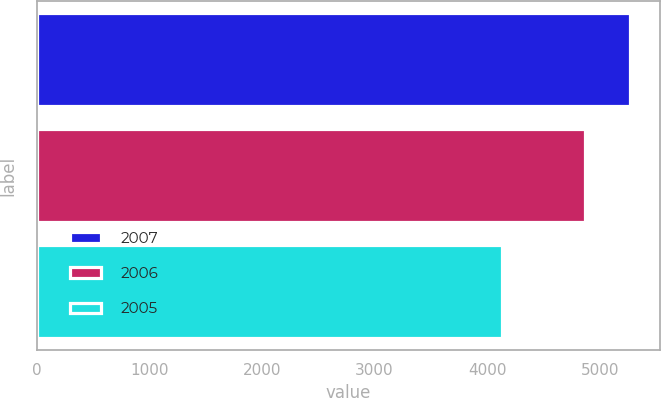Convert chart to OTSL. <chart><loc_0><loc_0><loc_500><loc_500><bar_chart><fcel>2007<fcel>2006<fcel>2005<nl><fcel>5268.4<fcel>4868.6<fcel>4133.3<nl></chart> 